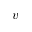<formula> <loc_0><loc_0><loc_500><loc_500>v</formula> 